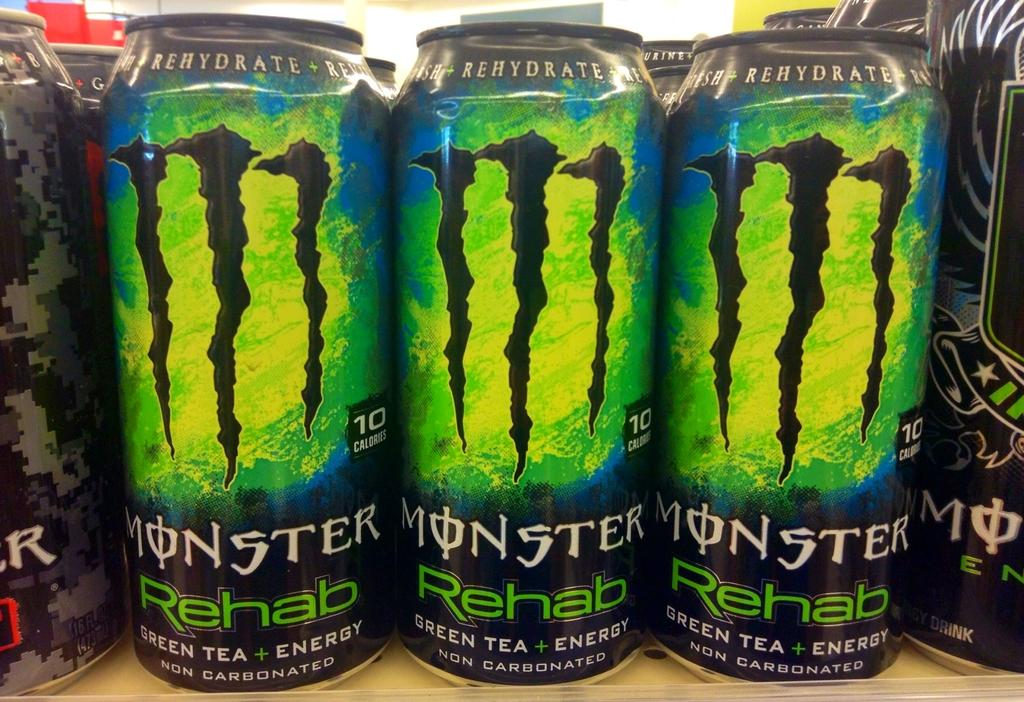<image>
Create a compact narrative representing the image presented. Three cans of Monster Rehab Green Tea Energy drink sit on a shelf. 